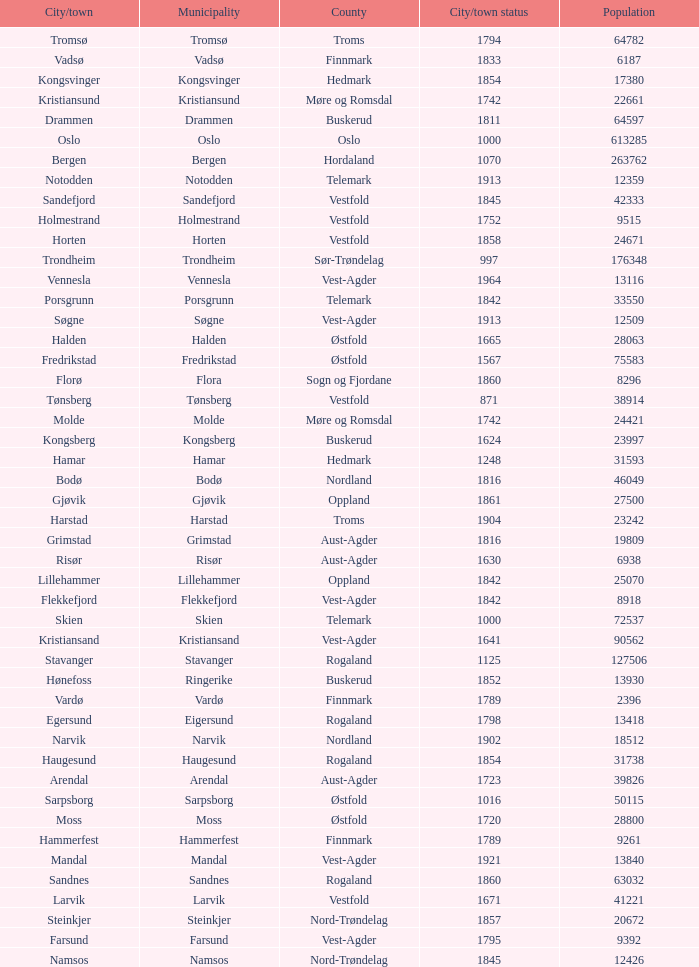Which municipalities located in the county of Finnmark have populations bigger than 6187.0? Hammerfest. 